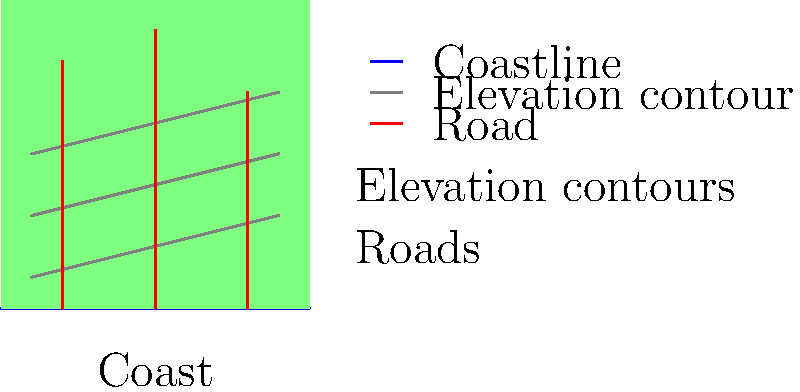Based on the satellite imagery above, which road would likely provide the safest evacuation route in case of a tsunami? To determine the safest evacuation route in case of a tsunami, we need to consider the following factors:

1. Distance from the coast: The further inland, the safer.
2. Elevation: Higher ground is safer during a tsunami.
3. Directness of the route: A straighter path allows for quicker evacuation.

Let's analyze each road:

1. Left road (at x=20):
   - Closest to the coast
   - Reaches up to the second elevation contour
   - Relatively straight

2. Middle road (at x=50):
   - Further from the coast than the left road
   - Reaches the highest elevation (third contour)
   - Straight path

3. Right road (at x=80):
   - Furthest from the coast
   - Only reaches the second elevation contour
   - Slightly shorter than the other roads

Considering these factors:
- The left road is the least safe due to its proximity to the coast.
- The right road is better in terms of distance from the coast but doesn't reach as high an elevation.
- The middle road offers the best combination of distance from the coast and elevation gain.

Therefore, the middle road (at x=50) would likely provide the safest evacuation route in case of a tsunami.
Answer: Middle road 